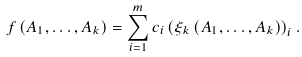<formula> <loc_0><loc_0><loc_500><loc_500>f \left ( A _ { 1 } , \dots , A _ { k } \right ) = \sum _ { i = 1 } ^ { m } c _ { i } \left ( \xi _ { k } \left ( A _ { 1 } , \dots , A _ { k } \right ) \right ) _ { i } .</formula> 